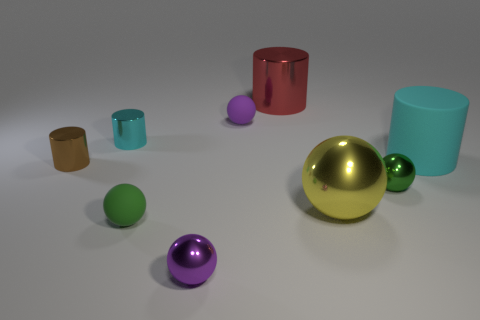What number of other objects are the same material as the brown cylinder?
Your answer should be very brief. 5. How many other things are the same shape as the yellow thing?
Your answer should be very brief. 4. What color is the large thing that is behind the yellow metal ball and in front of the large red metal cylinder?
Provide a succinct answer. Cyan. How many tiny metallic spheres are there?
Your answer should be compact. 2. Does the yellow shiny object have the same size as the purple shiny sphere?
Provide a succinct answer. No. Are there any rubber cylinders that have the same color as the big matte thing?
Provide a short and direct response. No. There is a tiny purple object in front of the green shiny thing; does it have the same shape as the small brown metallic thing?
Provide a succinct answer. No. How many yellow objects have the same size as the brown metallic cylinder?
Give a very brief answer. 0. There is a tiny purple ball that is behind the green matte object; how many purple things are on the left side of it?
Offer a terse response. 1. Is the purple ball behind the small green shiny thing made of the same material as the yellow thing?
Offer a terse response. No. 